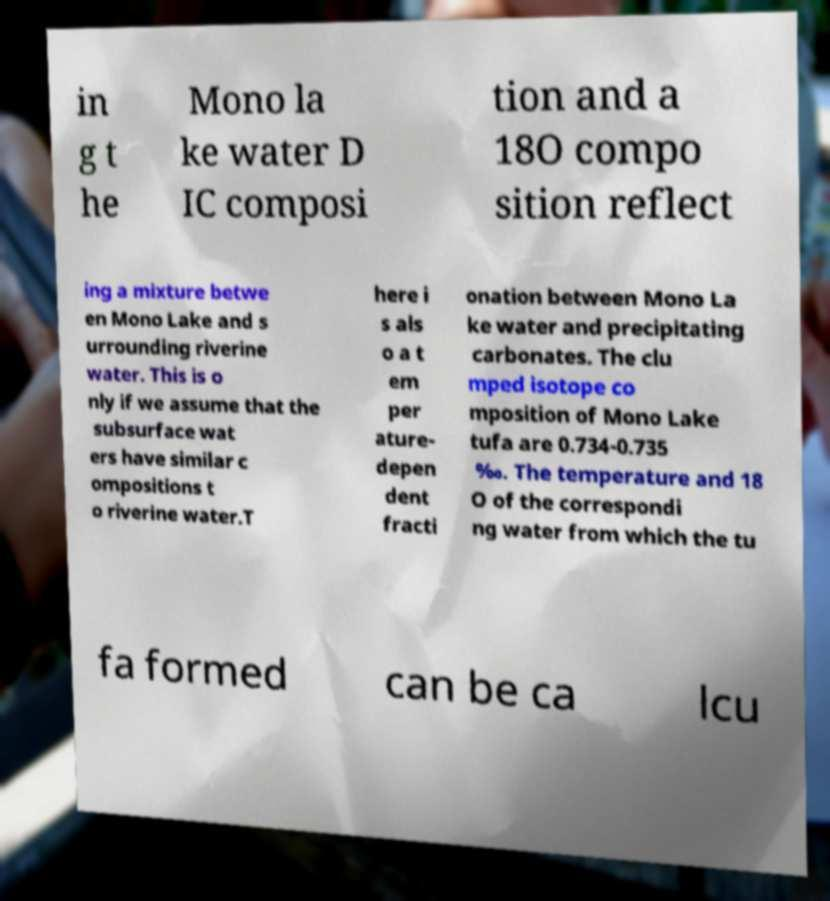What messages or text are displayed in this image? I need them in a readable, typed format. in g t he Mono la ke water D IC composi tion and a 18O compo sition reflect ing a mixture betwe en Mono Lake and s urrounding riverine water. This is o nly if we assume that the subsurface wat ers have similar c ompositions t o riverine water.T here i s als o a t em per ature- depen dent fracti onation between Mono La ke water and precipitating carbonates. The clu mped isotope co mposition of Mono Lake tufa are 0.734-0.735 ‰. The temperature and 18 O of the correspondi ng water from which the tu fa formed can be ca lcu 